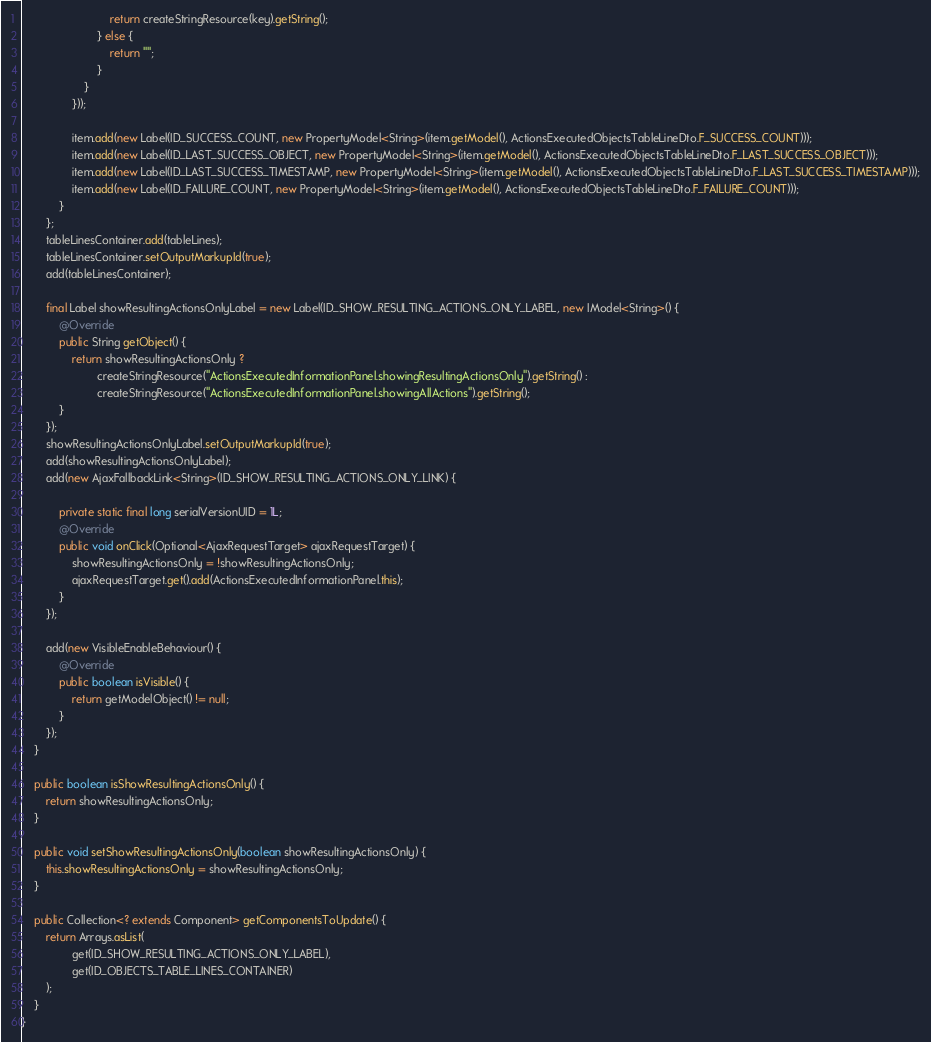<code> <loc_0><loc_0><loc_500><loc_500><_Java_>                            return createStringResource(key).getString();
                        } else {
                            return "";
                        }
                    }
                }));

                item.add(new Label(ID_SUCCESS_COUNT, new PropertyModel<String>(item.getModel(), ActionsExecutedObjectsTableLineDto.F_SUCCESS_COUNT)));
                item.add(new Label(ID_LAST_SUCCESS_OBJECT, new PropertyModel<String>(item.getModel(), ActionsExecutedObjectsTableLineDto.F_LAST_SUCCESS_OBJECT)));
                item.add(new Label(ID_LAST_SUCCESS_TIMESTAMP, new PropertyModel<String>(item.getModel(), ActionsExecutedObjectsTableLineDto.F_LAST_SUCCESS_TIMESTAMP)));
                item.add(new Label(ID_FAILURE_COUNT, new PropertyModel<String>(item.getModel(), ActionsExecutedObjectsTableLineDto.F_FAILURE_COUNT)));
            }
        };
        tableLinesContainer.add(tableLines);
        tableLinesContainer.setOutputMarkupId(true);
        add(tableLinesContainer);

        final Label showResultingActionsOnlyLabel = new Label(ID_SHOW_RESULTING_ACTIONS_ONLY_LABEL, new IModel<String>() {
            @Override
            public String getObject() {
                return showResultingActionsOnly ?
                        createStringResource("ActionsExecutedInformationPanel.showingResultingActionsOnly").getString() :
                        createStringResource("ActionsExecutedInformationPanel.showingAllActions").getString();
            }
        });
        showResultingActionsOnlyLabel.setOutputMarkupId(true);
        add(showResultingActionsOnlyLabel);
        add(new AjaxFallbackLink<String>(ID_SHOW_RESULTING_ACTIONS_ONLY_LINK) {

            private static final long serialVersionUID = 1L;
            @Override
            public void onClick(Optional<AjaxRequestTarget> ajaxRequestTarget) {
                showResultingActionsOnly = !showResultingActionsOnly;
                ajaxRequestTarget.get().add(ActionsExecutedInformationPanel.this);
            }
        });

        add(new VisibleEnableBehaviour() {
            @Override
            public boolean isVisible() {
                return getModelObject() != null;
            }
        });
    }

    public boolean isShowResultingActionsOnly() {
        return showResultingActionsOnly;
    }

    public void setShowResultingActionsOnly(boolean showResultingActionsOnly) {
        this.showResultingActionsOnly = showResultingActionsOnly;
    }

    public Collection<? extends Component> getComponentsToUpdate() {
        return Arrays.asList(
                get(ID_SHOW_RESULTING_ACTIONS_ONLY_LABEL),
                get(ID_OBJECTS_TABLE_LINES_CONTAINER)
        );
    }
}
</code> 